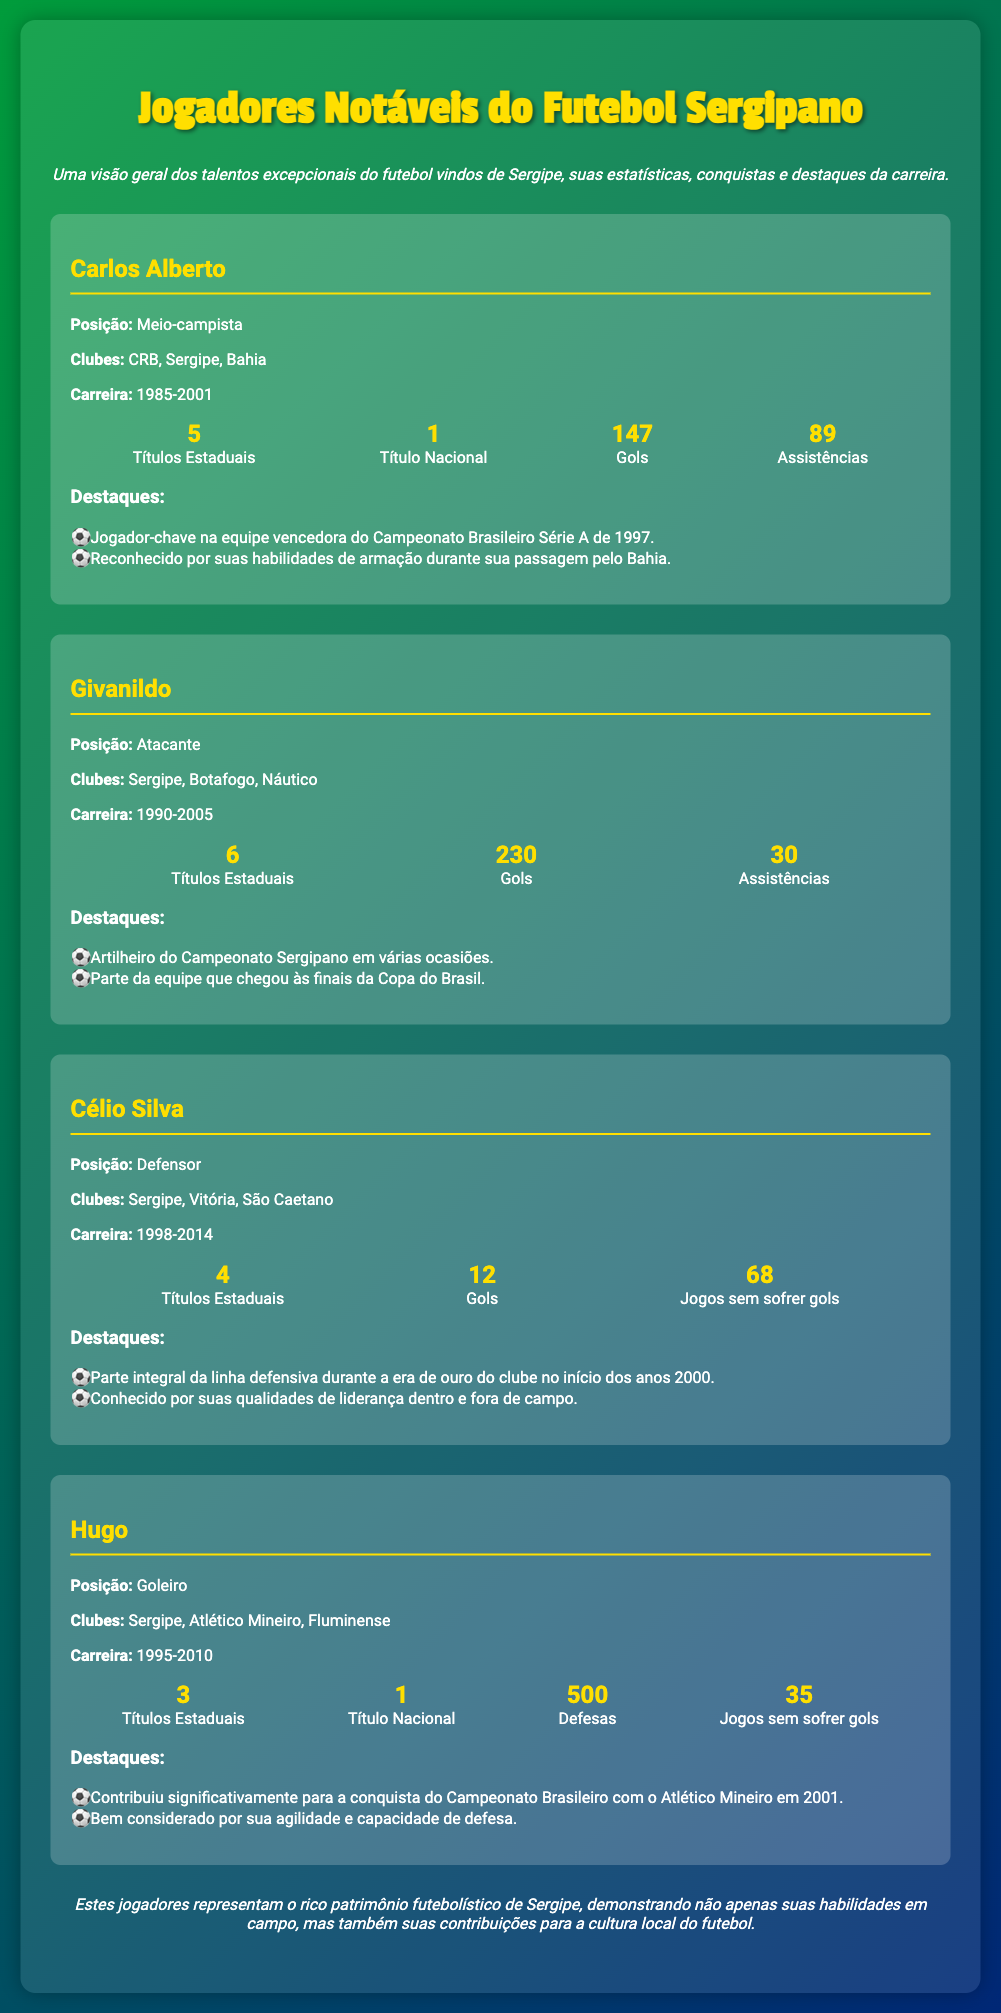What position did Carlos Alberto play? Carlos Alberto's position is indicated in the document under his profile.
Answer: Meio-campista How many goals did Givanildo score? Givanildo's total goals are mentioned in his player section of the document.
Answer: 230 What are the years of Célio Silva's career? Célio Silva's career years are listed in his profile as part of the information provided.
Answer: 1998-2014 How many clean sheets did Hugo achieve? The number of games without goals conceded by Hugo is specified in his statistics.
Answer: 35 What is the total number of state titles won by Carlos Alberto? The document specifically states the number of state titles won by Carlos Alberto.
Answer: 5 Which club did Givanildo play for the longest? The clubs Givanildo played for are mentioned, and reasoning leads to the conclusion about the club he is most associated with.
Answer: Sergipe What was a key highlight of Hugo's career? Highlights of Hugo's career, including significant contributions, are listed and indicate a major achievement.
Answer: Campeonato Brasileiro 2001 Who is recognized for their leadership on the field? The document states Célio Silva was known for his leadership skills, confirming his integral role.
Answer: Célio Silva What is the total number of assists Carlos Alberto provided? The number of assists by Carlos Alberto is clearly specified in his profile statistics.
Answer: 89 